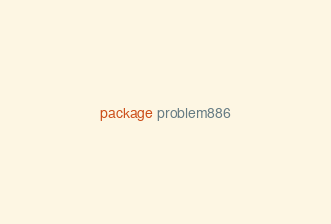<code> <loc_0><loc_0><loc_500><loc_500><_Go_>package problem886
</code> 